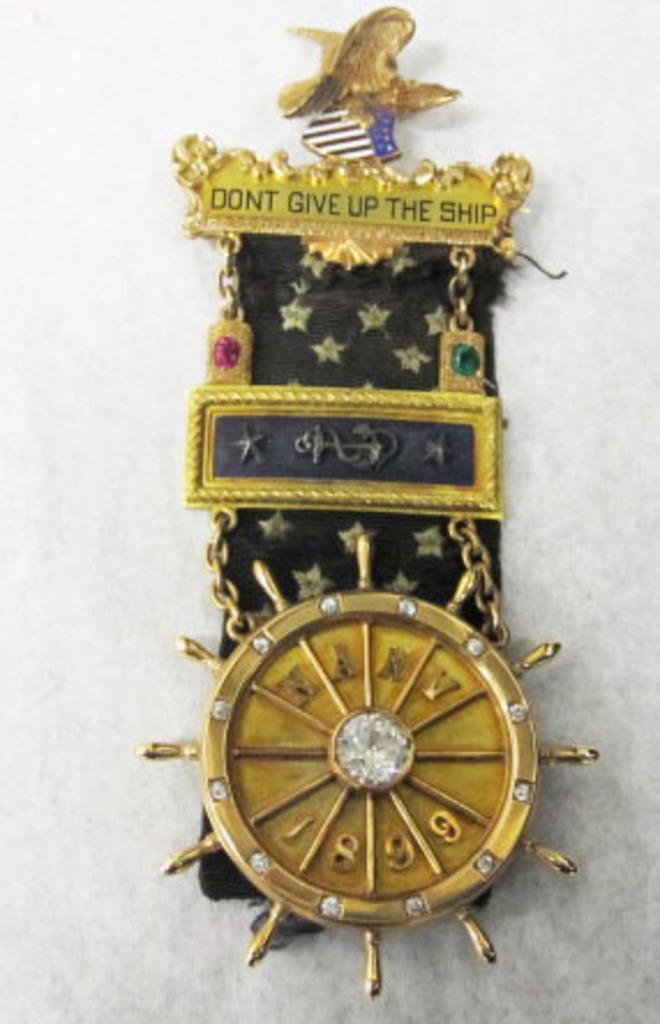What is the main subject of the image? The main subject of the image is a batch. Where is the batch located in the image? The batch is on a white surface in the image. How close is the batch to the viewer in the image? The batch is in the foreground of the image, which means it is close to the viewer. What type of poison is the crow using in the image? There is no crow or poison present in the image; it only features a batch on a white surface. 